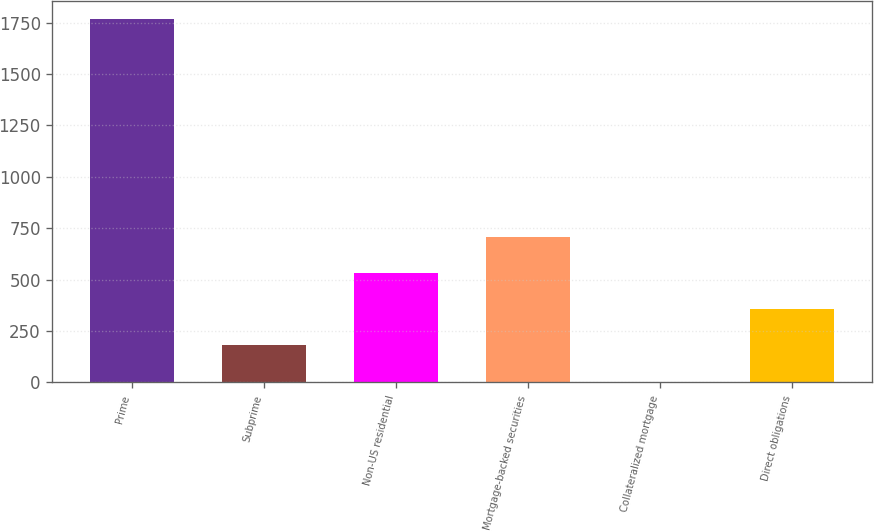Convert chart to OTSL. <chart><loc_0><loc_0><loc_500><loc_500><bar_chart><fcel>Prime<fcel>Subprime<fcel>Non-US residential<fcel>Mortgage-backed securities<fcel>Collateralized mortgage<fcel>Direct obligations<nl><fcel>1769<fcel>180.5<fcel>533.5<fcel>710<fcel>4<fcel>357<nl></chart> 